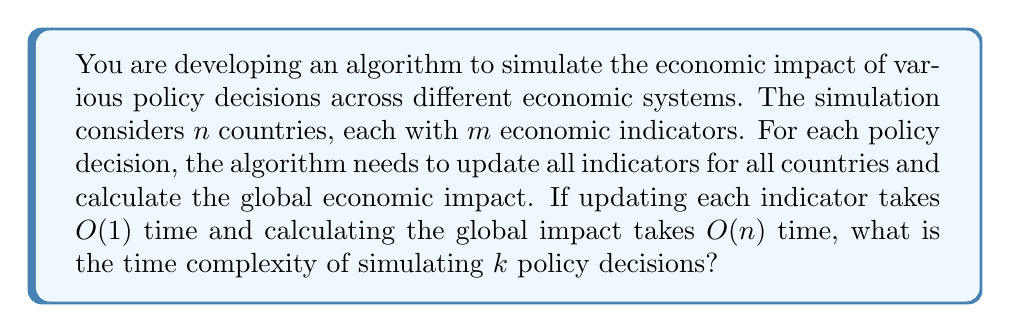Provide a solution to this math problem. Let's break down the problem and analyze it step by step:

1. For each policy decision:
   a. We need to update all indicators for all countries:
      - There are $n$ countries
      - Each country has $m$ indicators
      - Updating each indicator takes $O(1)$ time
      - So, updating all indicators for all countries takes: $O(n \cdot m)$ time

   b. After updating, we calculate the global economic impact:
      - This takes $O(n)$ time

   c. Total time for one policy decision: $O(n \cdot m) + O(n) = O(n \cdot m)$

2. We simulate $k$ policy decisions:
   - Each decision takes $O(n \cdot m)$ time
   - We do this $k$ times

3. Therefore, the total time complexity is:
   $$O(k \cdot n \cdot m)$$

This time complexity reflects that:
- The algorithm scales linearly with the number of policy decisions ($k$)
- It also scales linearly with the number of countries ($n$)
- And linearly with the number of economic indicators per country ($m$)

In the context of comparative economic systems, this algorithm allows for efficient simulation of various policy impacts across different economic models, enabling political scientists to analyze and compare the effectiveness of different governmental approaches to economic management.
Answer: $O(k \cdot n \cdot m)$ 